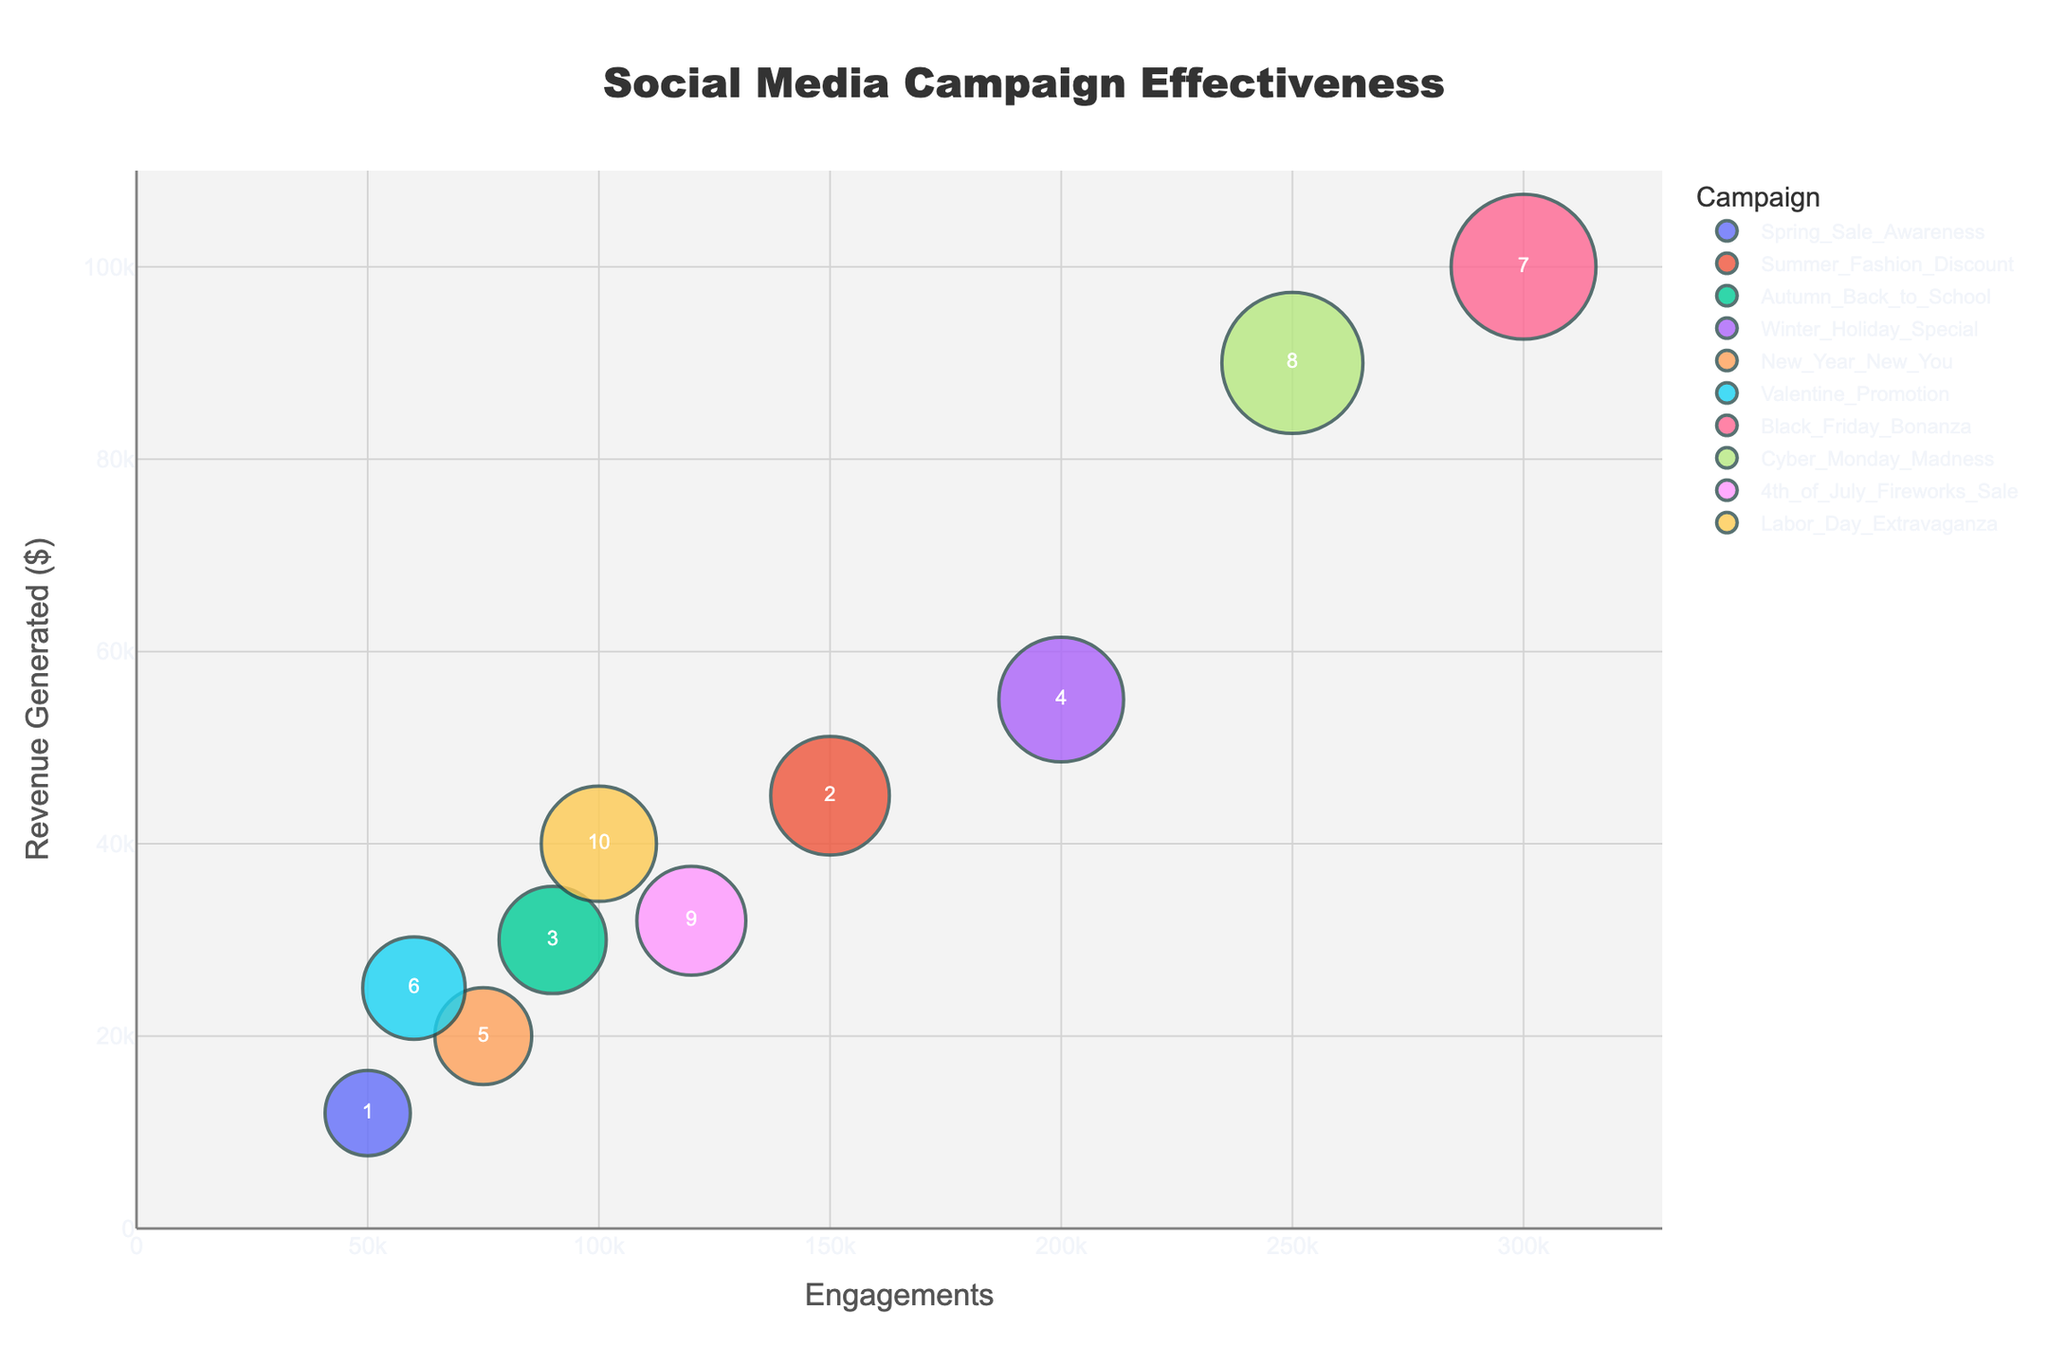What's the title of the figure? The title is located at the top center of the figure, with large and bold font size.
Answer: Social Media Campaign Effectiveness Which campaign generated the highest revenue? By looking at the y-axis, the campaign with the highest point vertically represents the highest revenue. The highest point corresponds to the "Black Friday Bonanza" campaign.
Answer: Black Friday Bonanza How many campaigns have revenue generated greater than $30,000? Identify points above the $30,000 mark on the y-axis and count them. These are "Summer Fashion Discount," "Autumn Back to School," "Winter Holiday Special," "Black Friday Bonanza," "Cyber Monday Madness," "Labor Day Extravaganza."
Answer: 6 Which campaign has the smallest bubble size? Bubble size is determined by the revenue generated, with smaller revenue resulting in smaller bubbles. The "Spring Sale Awareness" campaign has the smallest bubble.
Answer: Spring Sale Awareness What is the revenue generated by the New Year New You campaign? Locate the "New Year New You" campaign by identifying its hover name, then check its vertical position on the y-axis: approximately $20,000.
Answer: $20,000 What is the average revenue generated by all campaigns? Sum all the revenues and divide by the number of campaigns. (12000 + 45000 + 30000 + 55000 + 20000 + 25000 + 100000 + 90000 + 32000 + 40000) / 10 = 479,000 / 10 = 47,900.
Answer: $47,900 Which campaign has the highest engagement but generated less than $50,000 in revenue? Identify the campaign with the highest engagement points on the x-axis and check the corresponding y-axis values to be less than $50,000. "4th of July Fireworks Sale" has the highest engagement (120,000) below $50,000 revenue.
Answer: 4th of July Fireworks Sale What is the ID of the campaign with the highest revenue? Hover text shows the ID for each campaign. The highest revenue campaign is the "Black Friday Bonanza," verified through its ID: 7.
Answer: 7 Which campaign had more engagements, Black Friday Bonanza or Cyber Monday Madness? This is a comparison question that requires checking the x-axis positions for both campaigns. "Black Friday Bonanza" has 300,000 engagements, while "Cyber Monday Madness" has 250,000.
Answer: Black Friday Bonanza 